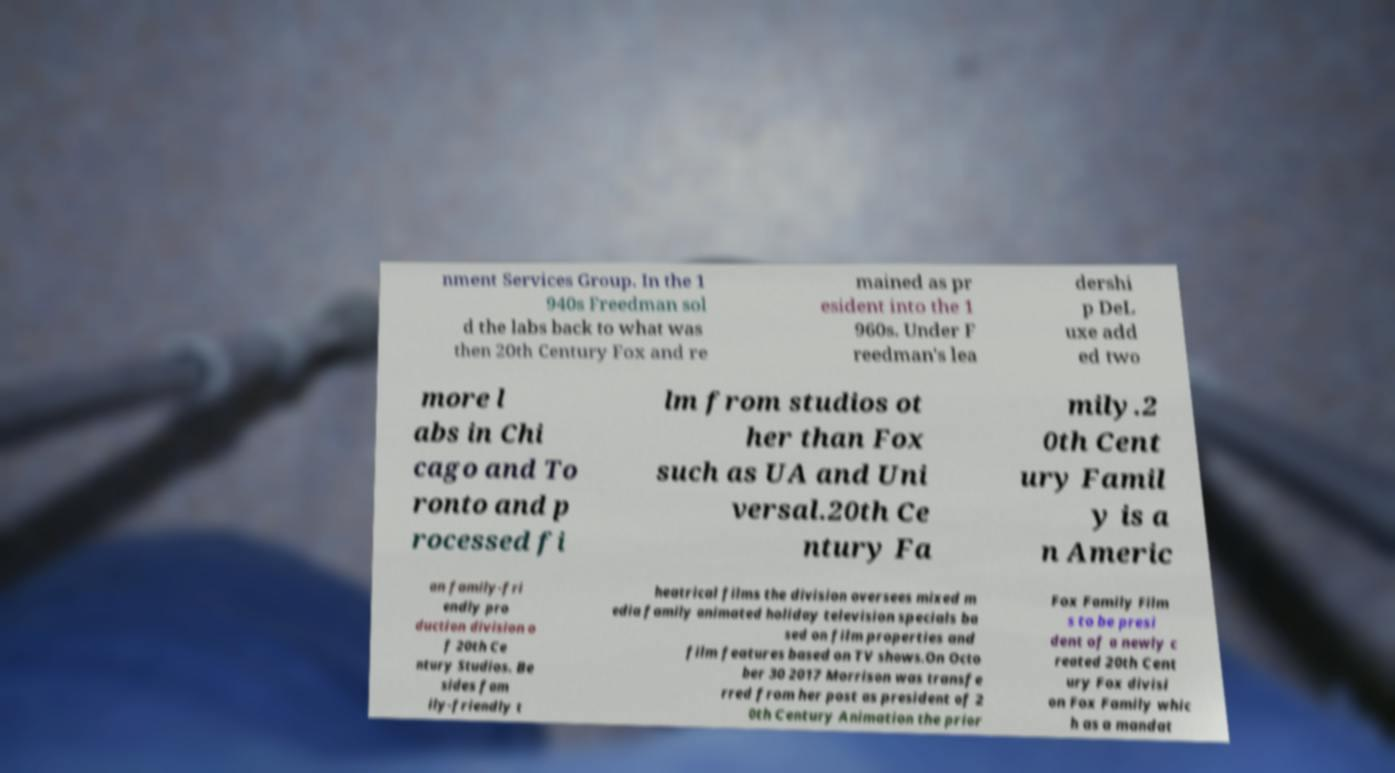I need the written content from this picture converted into text. Can you do that? nment Services Group. In the 1 940s Freedman sol d the labs back to what was then 20th Century Fox and re mained as pr esident into the 1 960s. Under F reedman's lea dershi p DeL uxe add ed two more l abs in Chi cago and To ronto and p rocessed fi lm from studios ot her than Fox such as UA and Uni versal.20th Ce ntury Fa mily.2 0th Cent ury Famil y is a n Americ an family-fri endly pro duction division o f 20th Ce ntury Studios. Be sides fam ily-friendly t heatrical films the division oversees mixed m edia family animated holiday television specials ba sed on film properties and film features based on TV shows.On Octo ber 30 2017 Morrison was transfe rred from her post as president of 2 0th Century Animation the prior Fox Family Film s to be presi dent of a newly c reated 20th Cent ury Fox divisi on Fox Family whic h as a mandat 